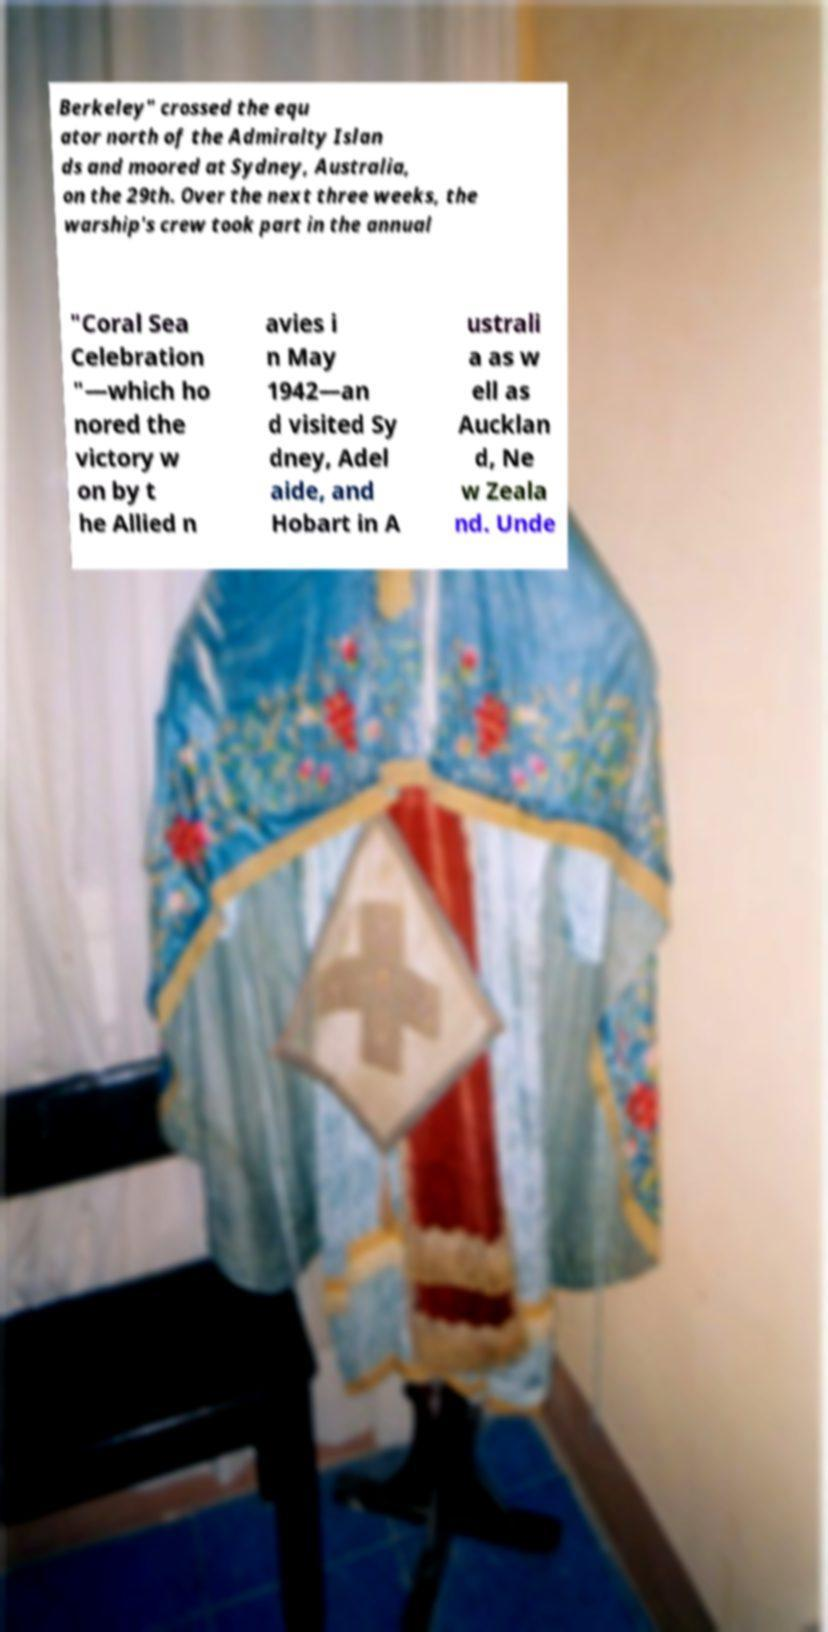For documentation purposes, I need the text within this image transcribed. Could you provide that? Berkeley" crossed the equ ator north of the Admiralty Islan ds and moored at Sydney, Australia, on the 29th. Over the next three weeks, the warship's crew took part in the annual "Coral Sea Celebration "—which ho nored the victory w on by t he Allied n avies i n May 1942—an d visited Sy dney, Adel aide, and Hobart in A ustrali a as w ell as Aucklan d, Ne w Zeala nd. Unde 